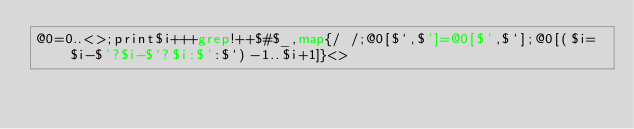<code> <loc_0><loc_0><loc_500><loc_500><_Perl_>@0=0..<>;print$i+++grep!++$#$_,map{/ /;@0[$`,$']=@0[$',$`];@0[($i=$i-$'?$i-$`?$i:$':$`)-1..$i+1]}<></code> 